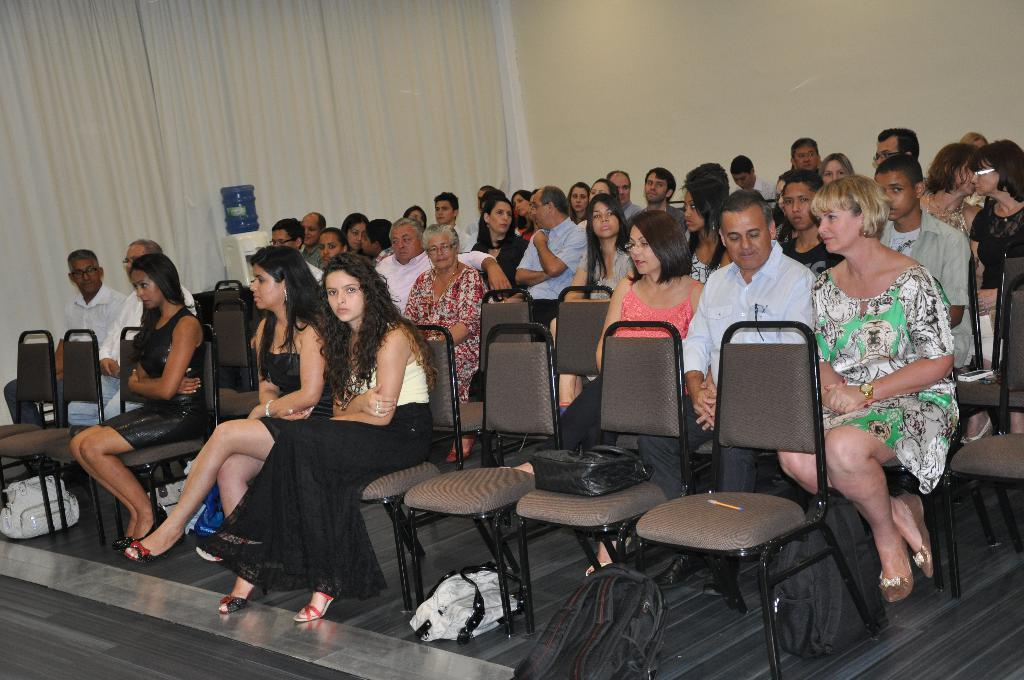How many people are in the image? There is a group of persons in the image. What are the persons in the image doing? The persons are sitting on chairs. What items can be seen at the bottom of the image? There are backpacks visible at the bottom of the image. What can be seen in the background of the image? There is a curtain and a wall in the background of the image. What type of plant is growing on the wall in the image? There is no plant growing on the wall in the image. How many stamps are visible on the curtain in the image? There are no stamps visible on the curtain in the image. 